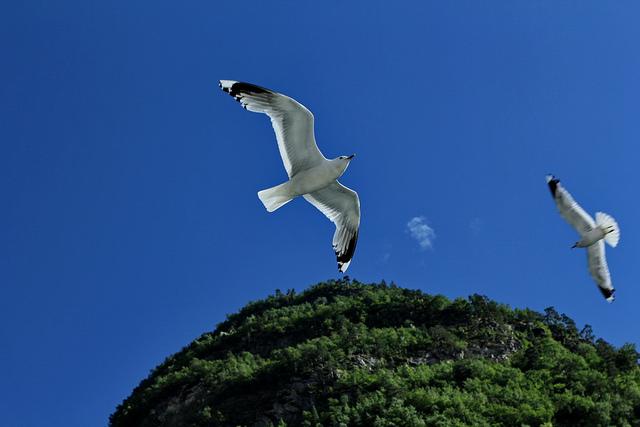What colors make up the birds?
Write a very short answer. White and black. How many clouds are in the sky?
Short answer required. 1. Which bird flies at a higher altitude?
Keep it brief. Right one. 